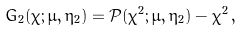Convert formula to latex. <formula><loc_0><loc_0><loc_500><loc_500>G _ { 2 } ( \chi ; \mu , \eta _ { 2 } ) = \mathcal { P } ( \chi ^ { 2 } ; \mu , \eta _ { 2 } ) - \chi ^ { 2 } \, ,</formula> 